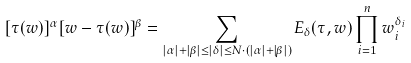<formula> <loc_0><loc_0><loc_500><loc_500>[ \tau ( w ) ] ^ { \alpha } [ w - \tau ( w ) ] ^ { \beta } = \sum _ { | \alpha | + | \beta | \leq | \delta | \leq N \cdot { ( | \alpha | + | \beta | ) } } E _ { \delta } ( \tau , w ) \prod _ { i = 1 } ^ { n } w _ { i } ^ { \delta _ { i } }</formula> 